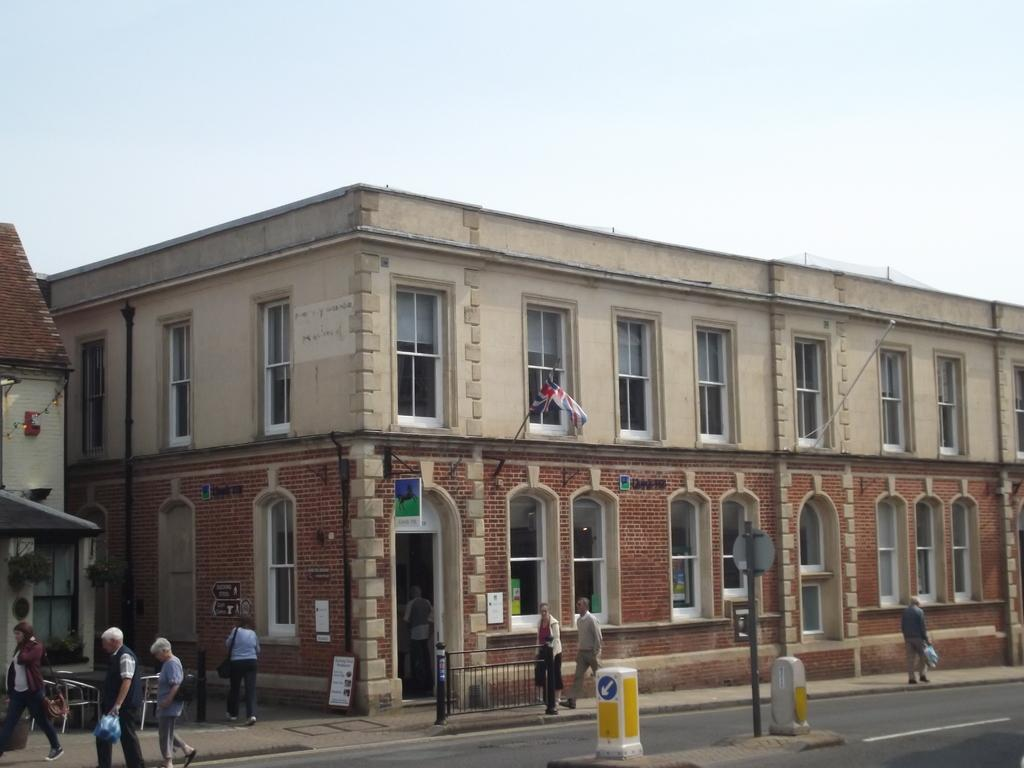What type of structures can be seen in the image? There are buildings in the image. What are the people in the image doing? People are walking on the road in the image. What safety feature is present in the image? Barrier poles are present in the image. What can be used for providing information or directions in the image? Sign boards are visible in the image. What is a symbol of national identity present in the image? There is a flag with a flag post in the image. What type of infrastructure is present in the image? Pipelines are present in the image. What can be seen in the background of the image? The sky is visible in the background of the image. What type of juice is being served at the competition in the image? There is no competition or juice present in the image. What fictional character can be seen interacting with the people in the image? There are no fictional characters present in the image; it features real people and objects. 